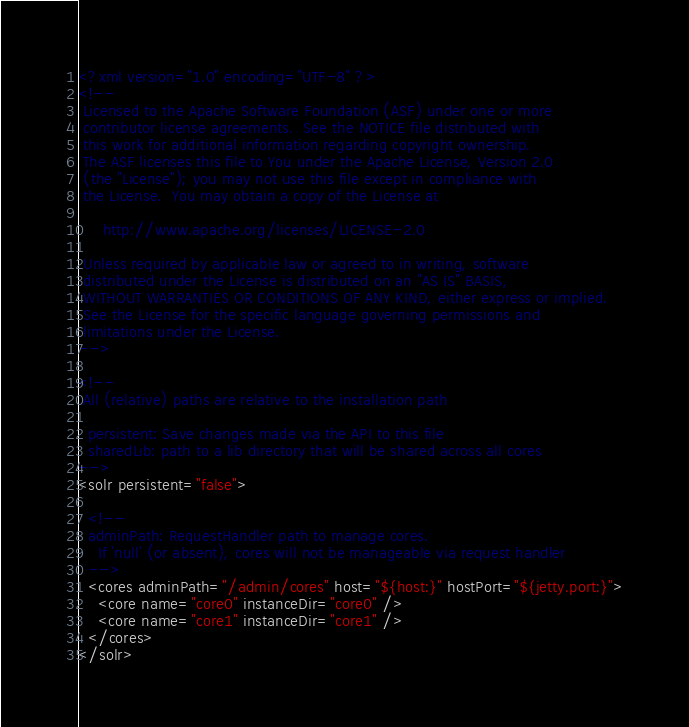Convert code to text. <code><loc_0><loc_0><loc_500><loc_500><_XML_><?xml version="1.0" encoding="UTF-8" ?>
<!--
 Licensed to the Apache Software Foundation (ASF) under one or more
 contributor license agreements.  See the NOTICE file distributed with
 this work for additional information regarding copyright ownership.
 The ASF licenses this file to You under the Apache License, Version 2.0
 (the "License"); you may not use this file except in compliance with
 the License.  You may obtain a copy of the License at

     http://www.apache.org/licenses/LICENSE-2.0

 Unless required by applicable law or agreed to in writing, software
 distributed under the License is distributed on an "AS IS" BASIS,
 WITHOUT WARRANTIES OR CONDITIONS OF ANY KIND, either express or implied.
 See the License for the specific language governing permissions and
 limitations under the License.
-->

<!--
 All (relative) paths are relative to the installation path
  
  persistent: Save changes made via the API to this file
  sharedLib: path to a lib directory that will be shared across all cores
-->
<solr persistent="false">

  <!--
  adminPath: RequestHandler path to manage cores.  
    If 'null' (or absent), cores will not be manageable via request handler
  -->
  <cores adminPath="/admin/cores" host="${host:}" hostPort="${jetty.port:}">
    <core name="core0" instanceDir="core0" />
    <core name="core1" instanceDir="core1" />
  </cores>
</solr>
</code> 